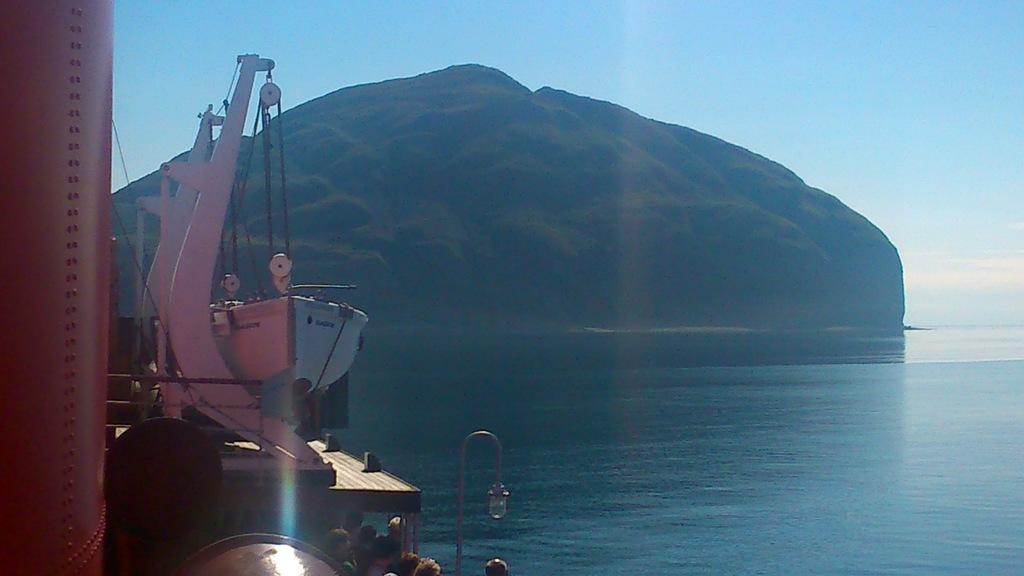What is the main subject of the image? The main subject of the image is a boat. What can be seen in the image besides the boat? There is a light, a pole, water, a mountain, a sky, and people wearing clothes visible in the image. What is the pole used for in the image? The purpose of the pole is not specified in the image, but it could be used for various purposes such as anchoring or signaling. What is the natural environment depicted in the image? The natural environment includes water, a mountain, and a sky. Can you see any cobwebs in the image? There are no cobwebs present in the image. What type of soda is being served on the boat in the image? There is no soda visible in the image; it only shows a boat, a light, a pole, water, a mountain, a sky, and people wearing clothes. 